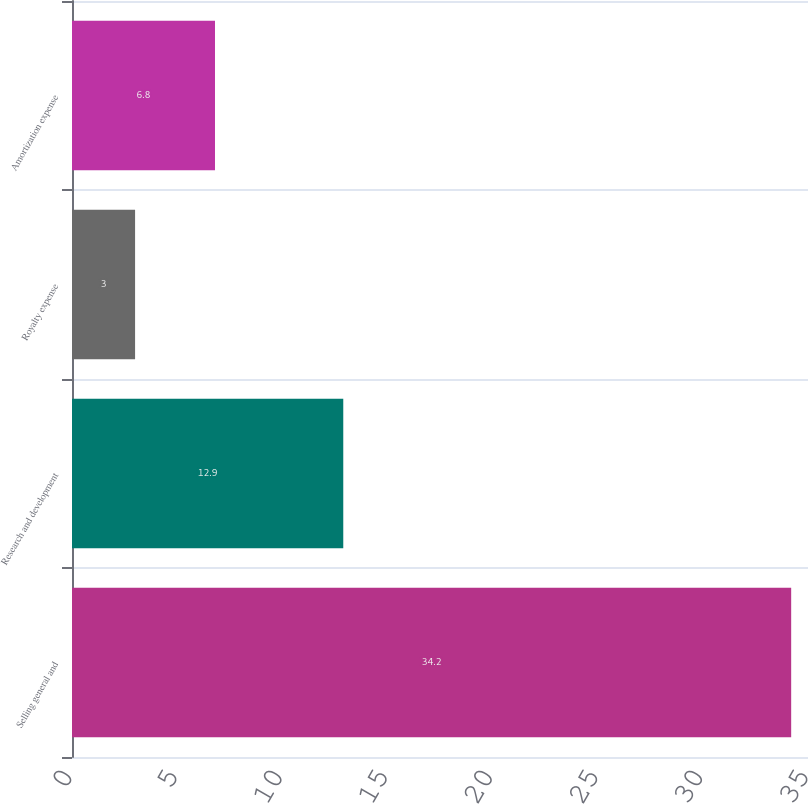<chart> <loc_0><loc_0><loc_500><loc_500><bar_chart><fcel>Selling general and<fcel>Research and development<fcel>Royalty expense<fcel>Amortization expense<nl><fcel>34.2<fcel>12.9<fcel>3<fcel>6.8<nl></chart> 